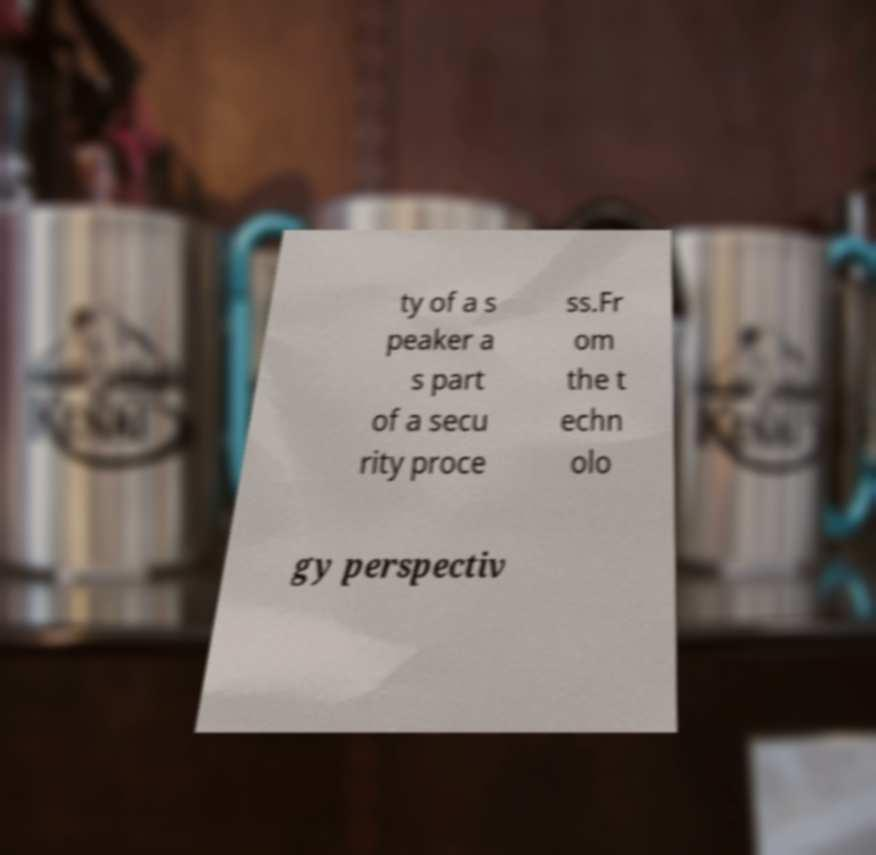What messages or text are displayed in this image? I need them in a readable, typed format. ty of a s peaker a s part of a secu rity proce ss.Fr om the t echn olo gy perspectiv 